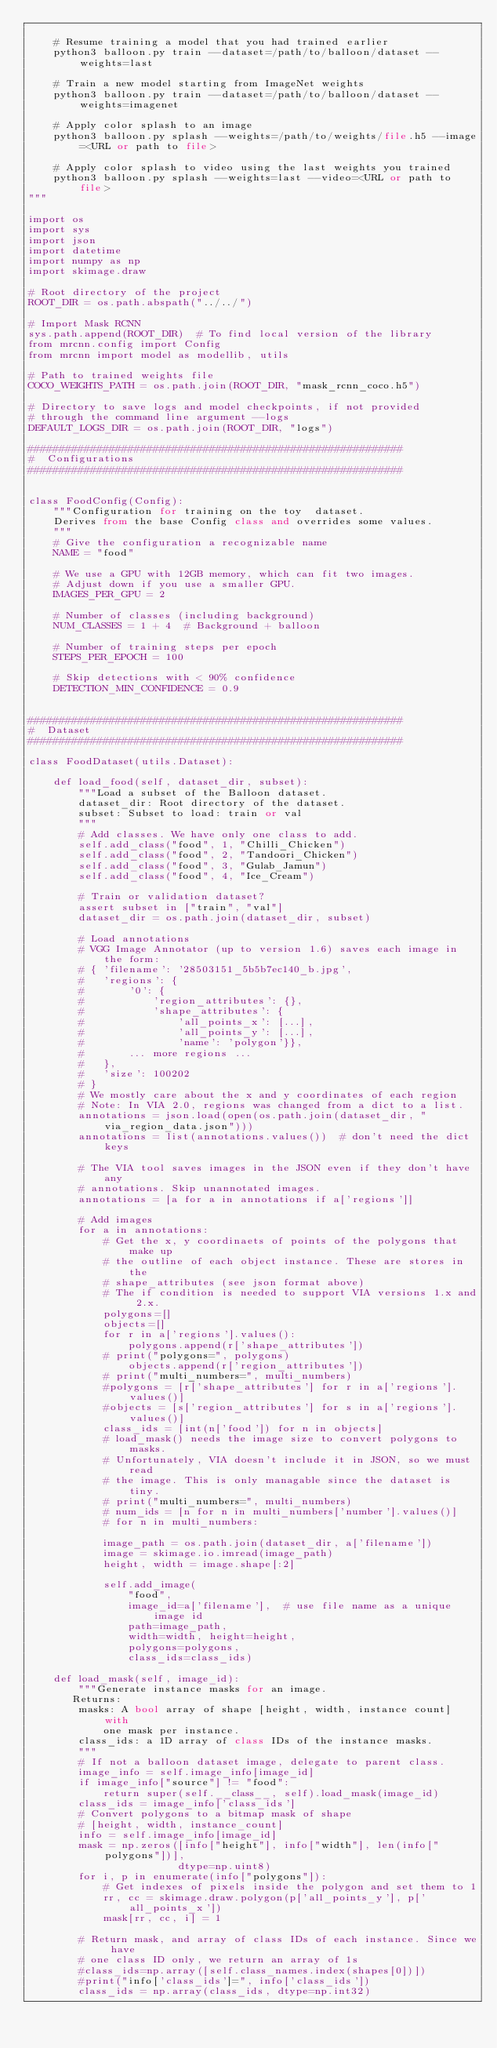Convert code to text. <code><loc_0><loc_0><loc_500><loc_500><_Python_>
    # Resume training a model that you had trained earlier
    python3 balloon.py train --dataset=/path/to/balloon/dataset --weights=last

    # Train a new model starting from ImageNet weights
    python3 balloon.py train --dataset=/path/to/balloon/dataset --weights=imagenet

    # Apply color splash to an image
    python3 balloon.py splash --weights=/path/to/weights/file.h5 --image=<URL or path to file>

    # Apply color splash to video using the last weights you trained
    python3 balloon.py splash --weights=last --video=<URL or path to file>
"""

import os
import sys
import json
import datetime
import numpy as np
import skimage.draw

# Root directory of the project
ROOT_DIR = os.path.abspath("../../")

# Import Mask RCNN
sys.path.append(ROOT_DIR)  # To find local version of the library
from mrcnn.config import Config
from mrcnn import model as modellib, utils

# Path to trained weights file
COCO_WEIGHTS_PATH = os.path.join(ROOT_DIR, "mask_rcnn_coco.h5")

# Directory to save logs and model checkpoints, if not provided
# through the command line argument --logs
DEFAULT_LOGS_DIR = os.path.join(ROOT_DIR, "logs")

############################################################
#  Configurations
############################################################


class FoodConfig(Config):
    """Configuration for training on the toy  dataset.
    Derives from the base Config class and overrides some values.
    """
    # Give the configuration a recognizable name
    NAME = "food"

    # We use a GPU with 12GB memory, which can fit two images.
    # Adjust down if you use a smaller GPU.
    IMAGES_PER_GPU = 2

    # Number of classes (including background)
    NUM_CLASSES = 1 + 4  # Background + balloon

    # Number of training steps per epoch
    STEPS_PER_EPOCH = 100

    # Skip detections with < 90% confidence
    DETECTION_MIN_CONFIDENCE = 0.9


############################################################
#  Dataset
############################################################

class FoodDataset(utils.Dataset):

    def load_food(self, dataset_dir, subset):
        """Load a subset of the Balloon dataset.
        dataset_dir: Root directory of the dataset.
        subset: Subset to load: train or val
        """
        # Add classes. We have only one class to add.
        self.add_class("food", 1, "Chilli_Chicken")
        self.add_class("food", 2, "Tandoori_Chicken")
        self.add_class("food", 3, "Gulab_Jamun")
        self.add_class("food", 4, "Ice_Cream")

        # Train or validation dataset?
        assert subset in ["train", "val"]
        dataset_dir = os.path.join(dataset_dir, subset)

        # Load annotations
        # VGG Image Annotator (up to version 1.6) saves each image in the form:
        # { 'filename': '28503151_5b5b7ec140_b.jpg',
        #   'regions': {
        #       '0': {
        #           'region_attributes': {},
        #           'shape_attributes': {
        #               'all_points_x': [...],
        #               'all_points_y': [...],
        #               'name': 'polygon'}},
        #       ... more regions ...
        #   },
        #   'size': 100202
        # }
        # We mostly care about the x and y coordinates of each region
        # Note: In VIA 2.0, regions was changed from a dict to a list.
        annotations = json.load(open(os.path.join(dataset_dir, "via_region_data.json")))
        annotations = list(annotations.values())  # don't need the dict keys

        # The VIA tool saves images in the JSON even if they don't have any
        # annotations. Skip unannotated images.
        annotations = [a for a in annotations if a['regions']]

        # Add images
        for a in annotations:
            # Get the x, y coordinaets of points of the polygons that make up
            # the outline of each object instance. These are stores in the
            # shape_attributes (see json format above)
            # The if condition is needed to support VIA versions 1.x and 2.x.
            polygons=[]
            objects=[]
            for r in a['regions'].values():
                polygons.append(r['shape_attributes'])
            # print("polygons=", polygons)
                objects.append(r['region_attributes'])
            # print("multi_numbers=", multi_numbers)
            #polygons = [r['shape_attributes'] for r in a['regions'].values()]
            #objects = [s['region_attributes'] for s in a['regions'].values()]
            class_ids = [int(n['food']) for n in objects]
			# load_mask() needs the image size to convert polygons to masks.
            # Unfortunately, VIA doesn't include it in JSON, so we must read
            # the image. This is only managable since the dataset is tiny.
            # print("multi_numbers=", multi_numbers)
            # num_ids = [n for n in multi_numbers['number'].values()]
            # for n in multi_numbers:
            
            image_path = os.path.join(dataset_dir, a['filename'])
            image = skimage.io.imread(image_path)
            height, width = image.shape[:2]

            self.add_image(
                "food",
                image_id=a['filename'],  # use file name as a unique image id
                path=image_path,
                width=width, height=height,
                polygons=polygons,
				class_ids=class_ids)

    def load_mask(self, image_id):
        """Generate instance masks for an image.
       Returns:
        masks: A bool array of shape [height, width, instance count] with
            one mask per instance.
        class_ids: a 1D array of class IDs of the instance masks.
        """
        # If not a balloon dataset image, delegate to parent class.
        image_info = self.image_info[image_id]
        if image_info["source"] != "food":
            return super(self.__class__, self).load_mask(image_id)
        class_ids = image_info['class_ids']
        # Convert polygons to a bitmap mask of shape
        # [height, width, instance_count]
        info = self.image_info[image_id]
        mask = np.zeros([info["height"], info["width"], len(info["polygons"])],
                        dtype=np.uint8)
        for i, p in enumerate(info["polygons"]):
            # Get indexes of pixels inside the polygon and set them to 1
            rr, cc = skimage.draw.polygon(p['all_points_y'], p['all_points_x'])
            mask[rr, cc, i] = 1

        # Return mask, and array of class IDs of each instance. Since we have
        # one class ID only, we return an array of 1s
        #class_ids=np.array([self.class_names.index(shapes[0])])
        #print("info['class_ids']=", info['class_ids'])
        class_ids = np.array(class_ids, dtype=np.int32)</code> 